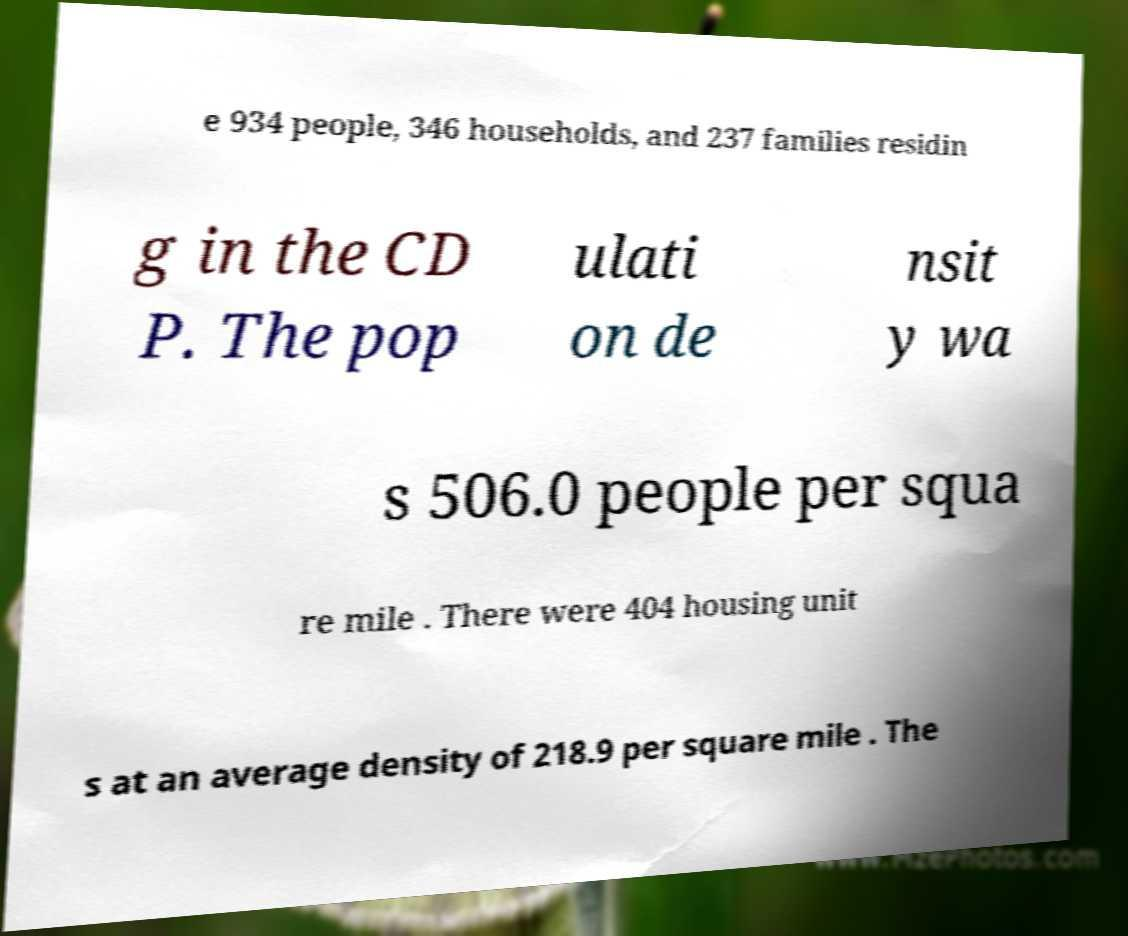Could you extract and type out the text from this image? e 934 people, 346 households, and 237 families residin g in the CD P. The pop ulati on de nsit y wa s 506.0 people per squa re mile . There were 404 housing unit s at an average density of 218.9 per square mile . The 